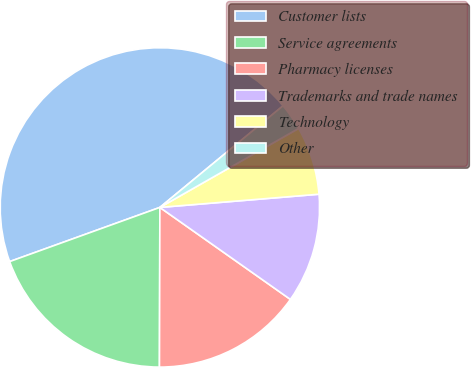Convert chart to OTSL. <chart><loc_0><loc_0><loc_500><loc_500><pie_chart><fcel>Customer lists<fcel>Service agreements<fcel>Pharmacy licenses<fcel>Trademarks and trade names<fcel>Technology<fcel>Other<nl><fcel>44.53%<fcel>19.45%<fcel>15.27%<fcel>11.09%<fcel>6.92%<fcel>2.74%<nl></chart> 